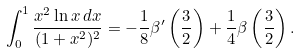Convert formula to latex. <formula><loc_0><loc_0><loc_500><loc_500>\int _ { 0 } ^ { 1 } \frac { x ^ { 2 } \ln x \, d x } { ( 1 + x ^ { 2 } ) ^ { 2 } } = - \frac { 1 } { 8 } \beta ^ { \prime } \left ( \frac { 3 } { 2 } \right ) + \frac { 1 } { 4 } \beta \left ( \frac { 3 } { 2 } \right ) .</formula> 